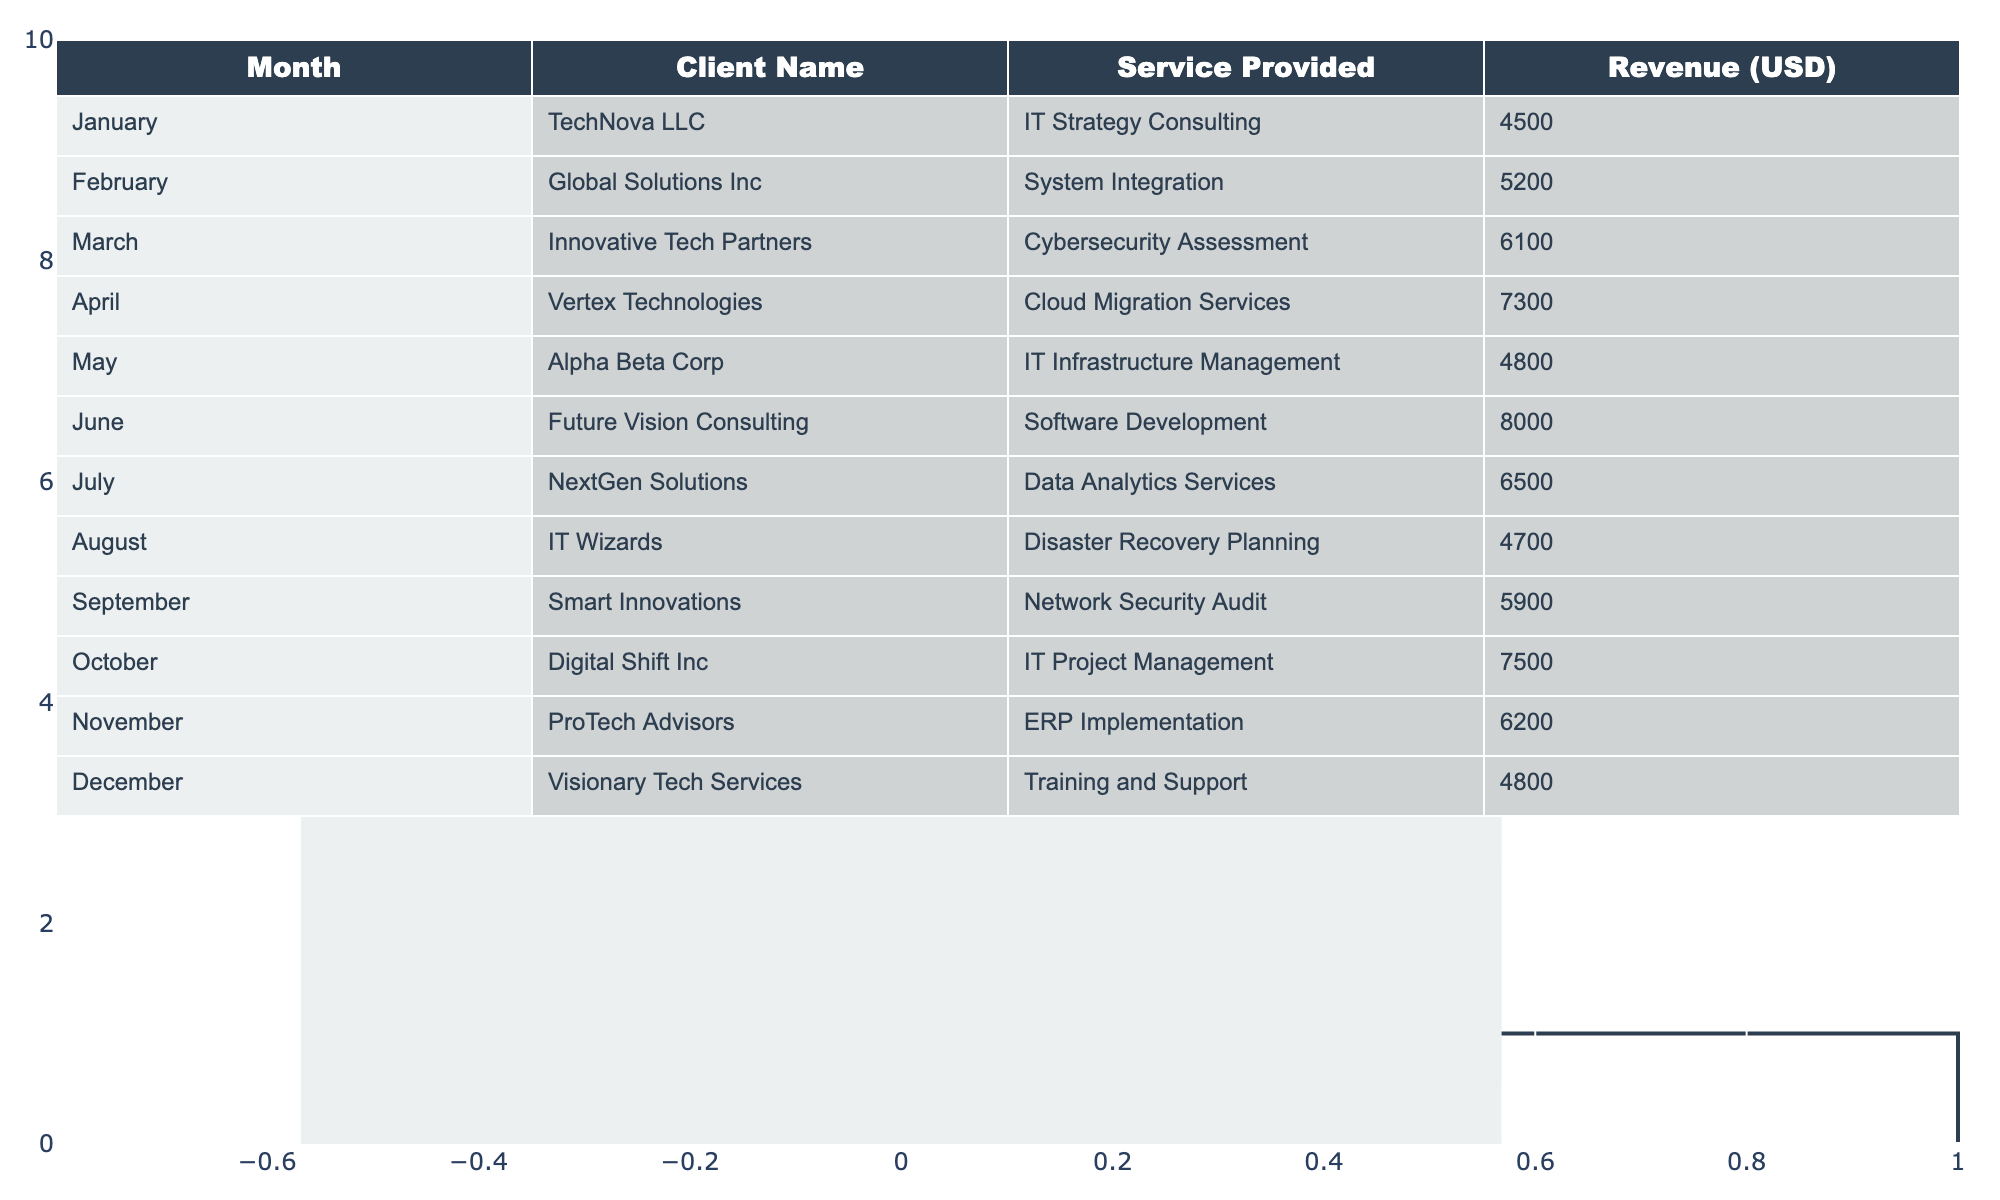What's the total revenue generated in June? The table shows that the revenue for June is 8000 USD, which is a direct retrieval from the provided data.
Answer: 8000 USD Which month had the highest revenue from IT consultancy services? Looking at the revenue column, the highest value is 8000 USD from June, which is the maximum revenue listed for any month in the table.
Answer: June What is the average revenue for the months listed? To find the average, sum all revenues (4500 + 5200 + 6100 + 7300 + 4800 + 8000 + 6500 + 4700 + 5900 + 7500 + 6200 + 4800) =  58000 USD. Divide by the number of months (12), which gives 58000/12 = 4833.33.
Answer: 4833.33 USD Was the revenue in October higher than in September? The table shows that October revenue is 7500 USD and September is 5900 USD, so 7500 is greater than 5900.
Answer: Yes What is the difference in revenue between the months of April and February? The revenue for April is 7300 USD and for February is 5200 USD. To find the difference, subtract February's from April's revenue: 7300 - 5200 = 2100 USD.
Answer: 2100 USD Over the entire year, which service provided generated the highest revenue? From the table, the service provided in June (Software Development) generated the highest revenue of 8000 USD compared to others.
Answer: Software Development Is the revenue from IT Strategy Consulting greater than the average revenue for the year? The revenue for IT Strategy Consulting is 4500 USD, and the average calculated is 4833.33 USD. Comparing these, 4500 is less than 4833.33.
Answer: No How much more revenue was generated in December compared to May? From the table, December is 4800 USD and May is 4800 USD, and calculating the difference: 4800 - 4800 = 0.
Answer: 0 USD If we combine the revenues of all the months with services related to 'Security' (Cybersecurity Assessment and Network Security Audit), what would that total be? Cybersecurity Assessment in March is 6100 USD and Network Security Audit in September is 5900 USD. Summing these gives 6100 + 5900 = 12000 USD.
Answer: 12000 USD Which month experienced a drop in revenue compared to the previous month? Reviewing the months, August (4700 USD) dropped from July (6500 USD). Hence, August is the month with a revenue drop.
Answer: August What was the total revenue for the first half of the year (January to June)? The total for this period includes (4500 + 5200 + 6100 + 7300 + 4800 + 8000) = 32900 USD.
Answer: 32900 USD 